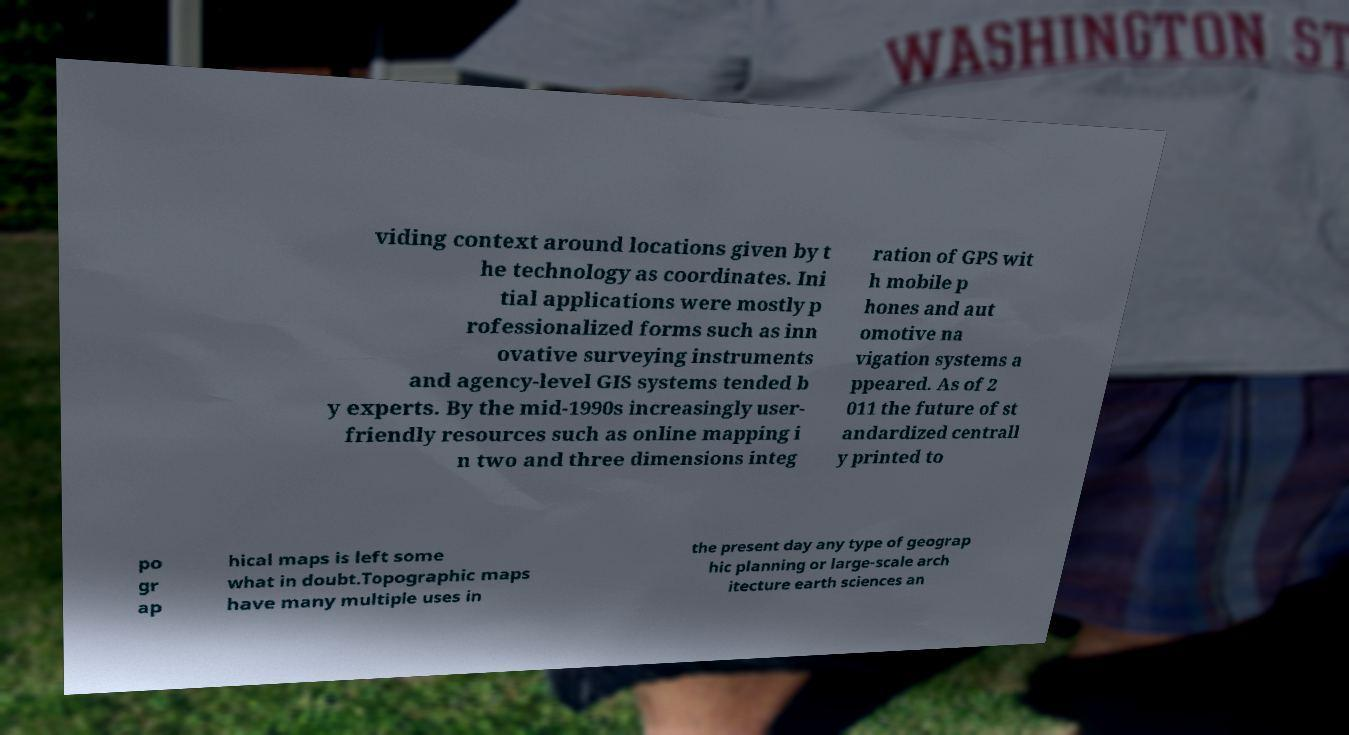Can you accurately transcribe the text from the provided image for me? viding context around locations given by t he technology as coordinates. Ini tial applications were mostly p rofessionalized forms such as inn ovative surveying instruments and agency-level GIS systems tended b y experts. By the mid-1990s increasingly user- friendly resources such as online mapping i n two and three dimensions integ ration of GPS wit h mobile p hones and aut omotive na vigation systems a ppeared. As of 2 011 the future of st andardized centrall y printed to po gr ap hical maps is left some what in doubt.Topographic maps have many multiple uses in the present day any type of geograp hic planning or large-scale arch itecture earth sciences an 